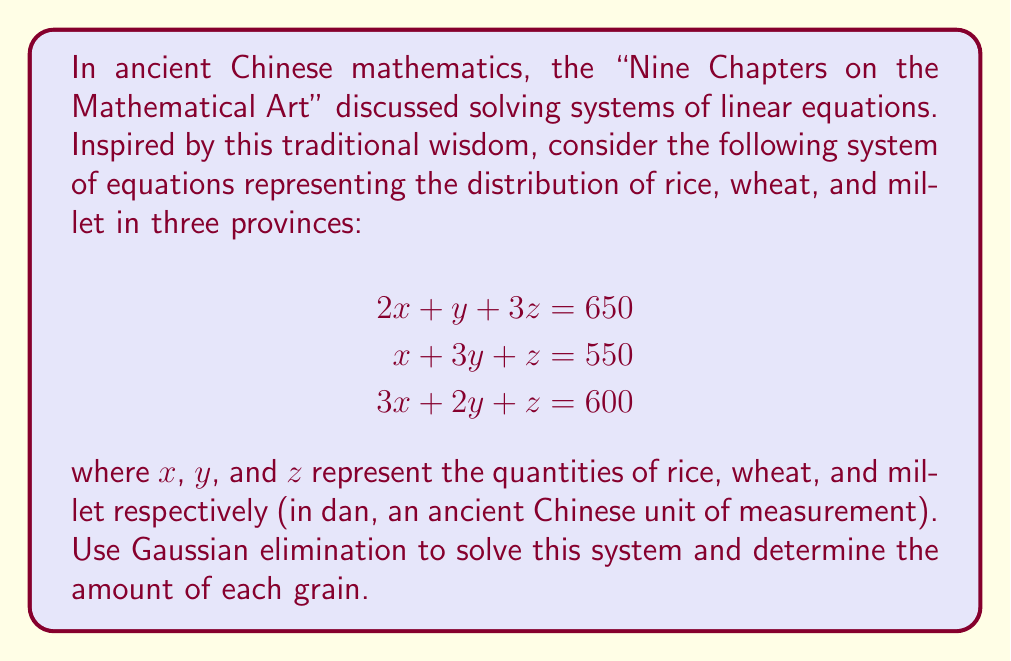Show me your answer to this math problem. Let's solve this system using Gaussian elimination, a method that aligns with the systematic approach valued in traditional Chinese education:

1) First, write the augmented matrix:

   $$\begin{bmatrix}
   2 & 1 & 3 & | & 650 \\
   1 & 3 & 1 & | & 550 \\
   3 & 2 & 1 & | & 600
   \end{bmatrix}$$

2) Use the first row to eliminate the first column in the second and third rows:
   
   R2 = R2 - $\frac{1}{2}$R1
   R3 = R3 - $\frac{3}{2}$R1

   $$\begin{bmatrix}
   2 & 1 & 3 & | & 650 \\
   0 & \frac{5}{2} & -\frac{1}{2} & | & 225 \\
   0 & \frac{1}{2} & -\frac{7}{2} & | & -375
   \end{bmatrix}$$

3) Use the second row to eliminate the second column in the third row:
   
   R3 = R3 - $\frac{1}{5}$R2

   $$\begin{bmatrix}
   2 & 1 & 3 & | & 650 \\
   0 & \frac{5}{2} & -\frac{1}{2} & | & 225 \\
   0 & 0 & -\frac{16}{5} & | & -420
   \end{bmatrix}$$

4) Now we have an upper triangular matrix. Solve for z:

   $-\frac{16}{5}z = -420$
   $z = 131.25$

5) Substitute z into the second equation:

   $\frac{5}{2}y - \frac{1}{2}(131.25) = 225$
   $\frac{5}{2}y = 290.625$
   $y = 116.25$

6) Finally, substitute y and z into the first equation:

   $2x + 116.25 + 3(131.25) = 650$
   $2x = 140$
   $x = 70$

Therefore, the solution is $x = 70$, $y = 116.25$, and $z = 131.25$.
Answer: Rice (x): 70 dan
Wheat (y): 116.25 dan
Millet (z): 131.25 dan 